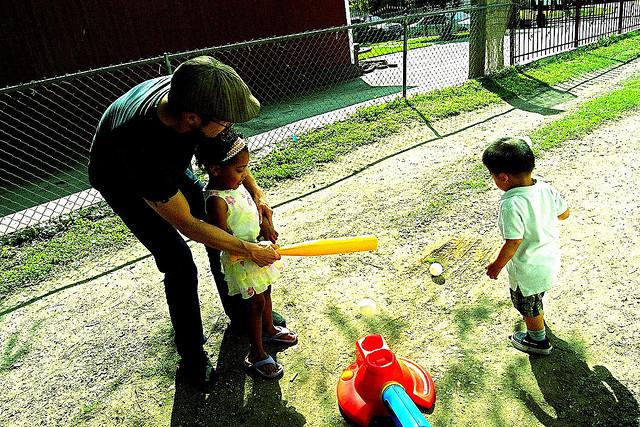What is the man teaching the girl?
Answer briefly. Baseball. How many children are there?
Keep it brief. 2. Where are they?
Quick response, please. Park. 